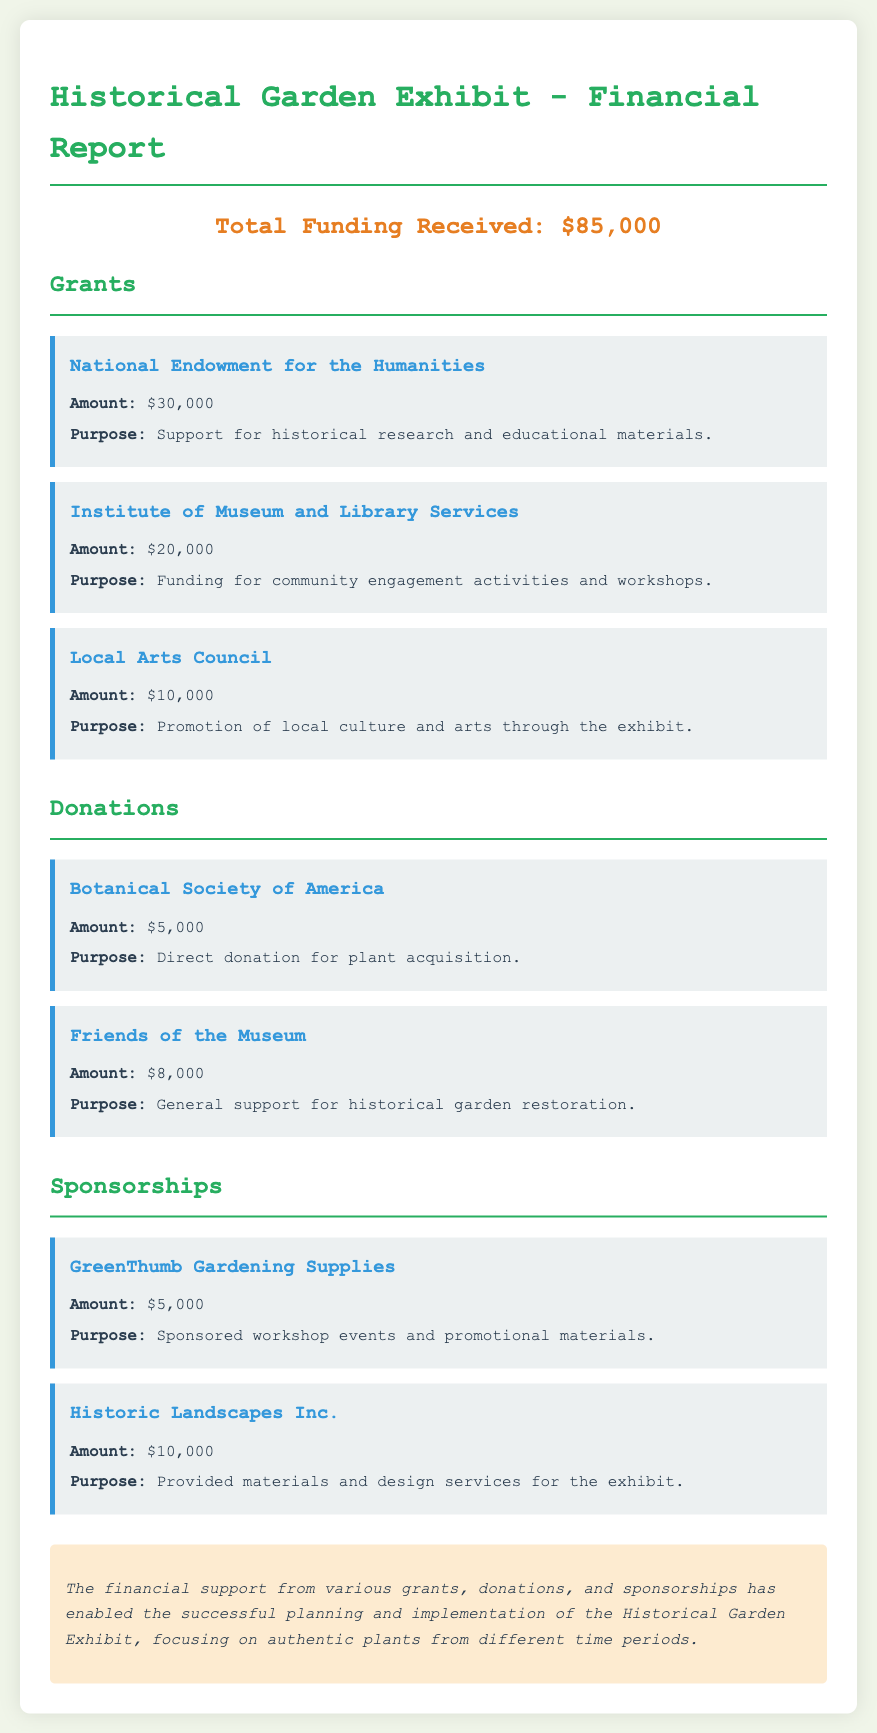What is the total funding received? The total funding received is explicitly stated at the top of the report.
Answer: $85,000 How much was received from the National Endowment for the Humanities? This figure is mentioned under the grants section of the document.
Answer: $30,000 What is the purpose of the funding from the Institute of Museum and Library Services? The purpose of the funding is detailed in the corresponding section of the document.
Answer: Funding for community engagement activities and workshops Who donated $5,000 for plant acquisition? This information is provided in the donations section of the report.
Answer: Botanical Society of America What is the amount of funding from Historic Landscapes Inc.? The amount is specified under the sponsorships section.
Answer: $10,000 Which organization provided the highest grant amount? This requires reasoning across all grant entries to identify the maximal amount.
Answer: National Endowment for the Humanities How many sources of funding are listed in the document? Each funding category includes multiple entries which need to be counted.
Answer: 7 What is the purpose of the donation from Friends of the Museum? The purpose is mentioned in the donations section, and it requires looking specifically at their line.
Answer: General support for historical garden restoration What type of financial support is provided by GreenThumb Gardening Supplies? The document categorizes the funding types, and the reasoning includes checking against sponsors.
Answer: Sponsored workshop events and promotional materials 